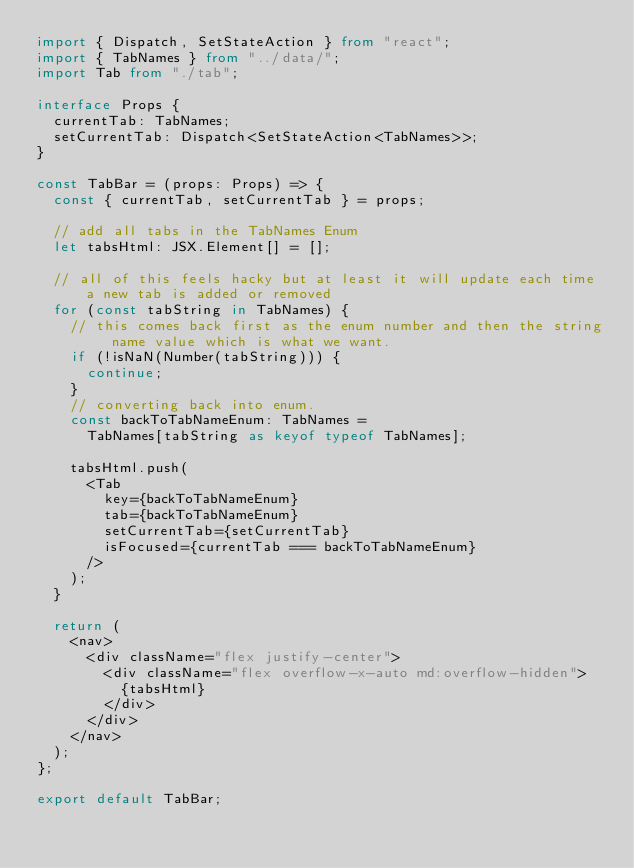<code> <loc_0><loc_0><loc_500><loc_500><_TypeScript_>import { Dispatch, SetStateAction } from "react";
import { TabNames } from "../data/";
import Tab from "./tab";

interface Props {
  currentTab: TabNames;
  setCurrentTab: Dispatch<SetStateAction<TabNames>>;
}

const TabBar = (props: Props) => {
  const { currentTab, setCurrentTab } = props;

  // add all tabs in the TabNames Enum
  let tabsHtml: JSX.Element[] = [];

  // all of this feels hacky but at least it will update each time a new tab is added or removed
  for (const tabString in TabNames) {
    // this comes back first as the enum number and then the string name value which is what we want.
    if (!isNaN(Number(tabString))) {
      continue;
    }
    // converting back into enum.
    const backToTabNameEnum: TabNames =
      TabNames[tabString as keyof typeof TabNames];

    tabsHtml.push(
      <Tab
        key={backToTabNameEnum}
        tab={backToTabNameEnum}
        setCurrentTab={setCurrentTab}
        isFocused={currentTab === backToTabNameEnum}
      />
    );
  }

  return (
    <nav>
      <div className="flex justify-center">
        <div className="flex overflow-x-auto md:overflow-hidden">
          {tabsHtml}
        </div>
      </div>
    </nav>
  );
};

export default TabBar;
</code> 